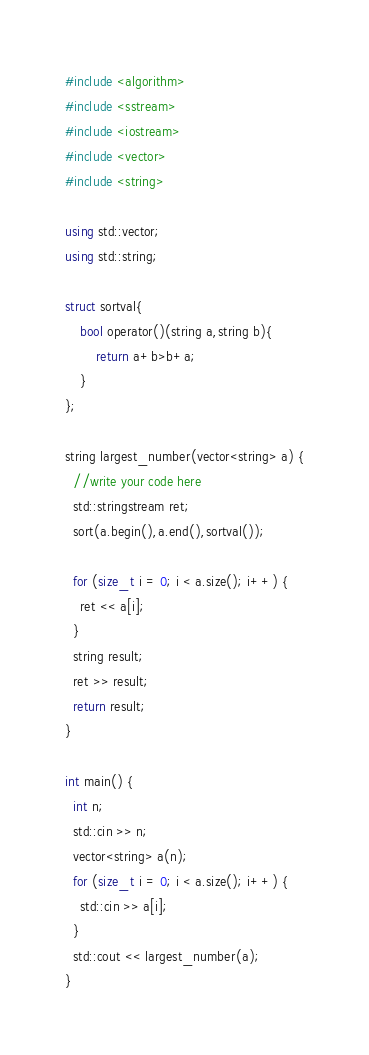<code> <loc_0><loc_0><loc_500><loc_500><_C++_>#include <algorithm>
#include <sstream>
#include <iostream>
#include <vector>
#include <string>

using std::vector;
using std::string;

struct sortval{
	bool operator()(string a,string b){
		return a+b>b+a;
	}
};

string largest_number(vector<string> a) {
  //write your code here
  std::stringstream ret;
  sort(a.begin(),a.end(),sortval());
  
  for (size_t i = 0; i < a.size(); i++) {
    ret << a[i];
  }
  string result;
  ret >> result;
  return result;
}

int main() {
  int n;
  std::cin >> n;
  vector<string> a(n);
  for (size_t i = 0; i < a.size(); i++) {
    std::cin >> a[i];
  }
  std::cout << largest_number(a);
}
</code> 